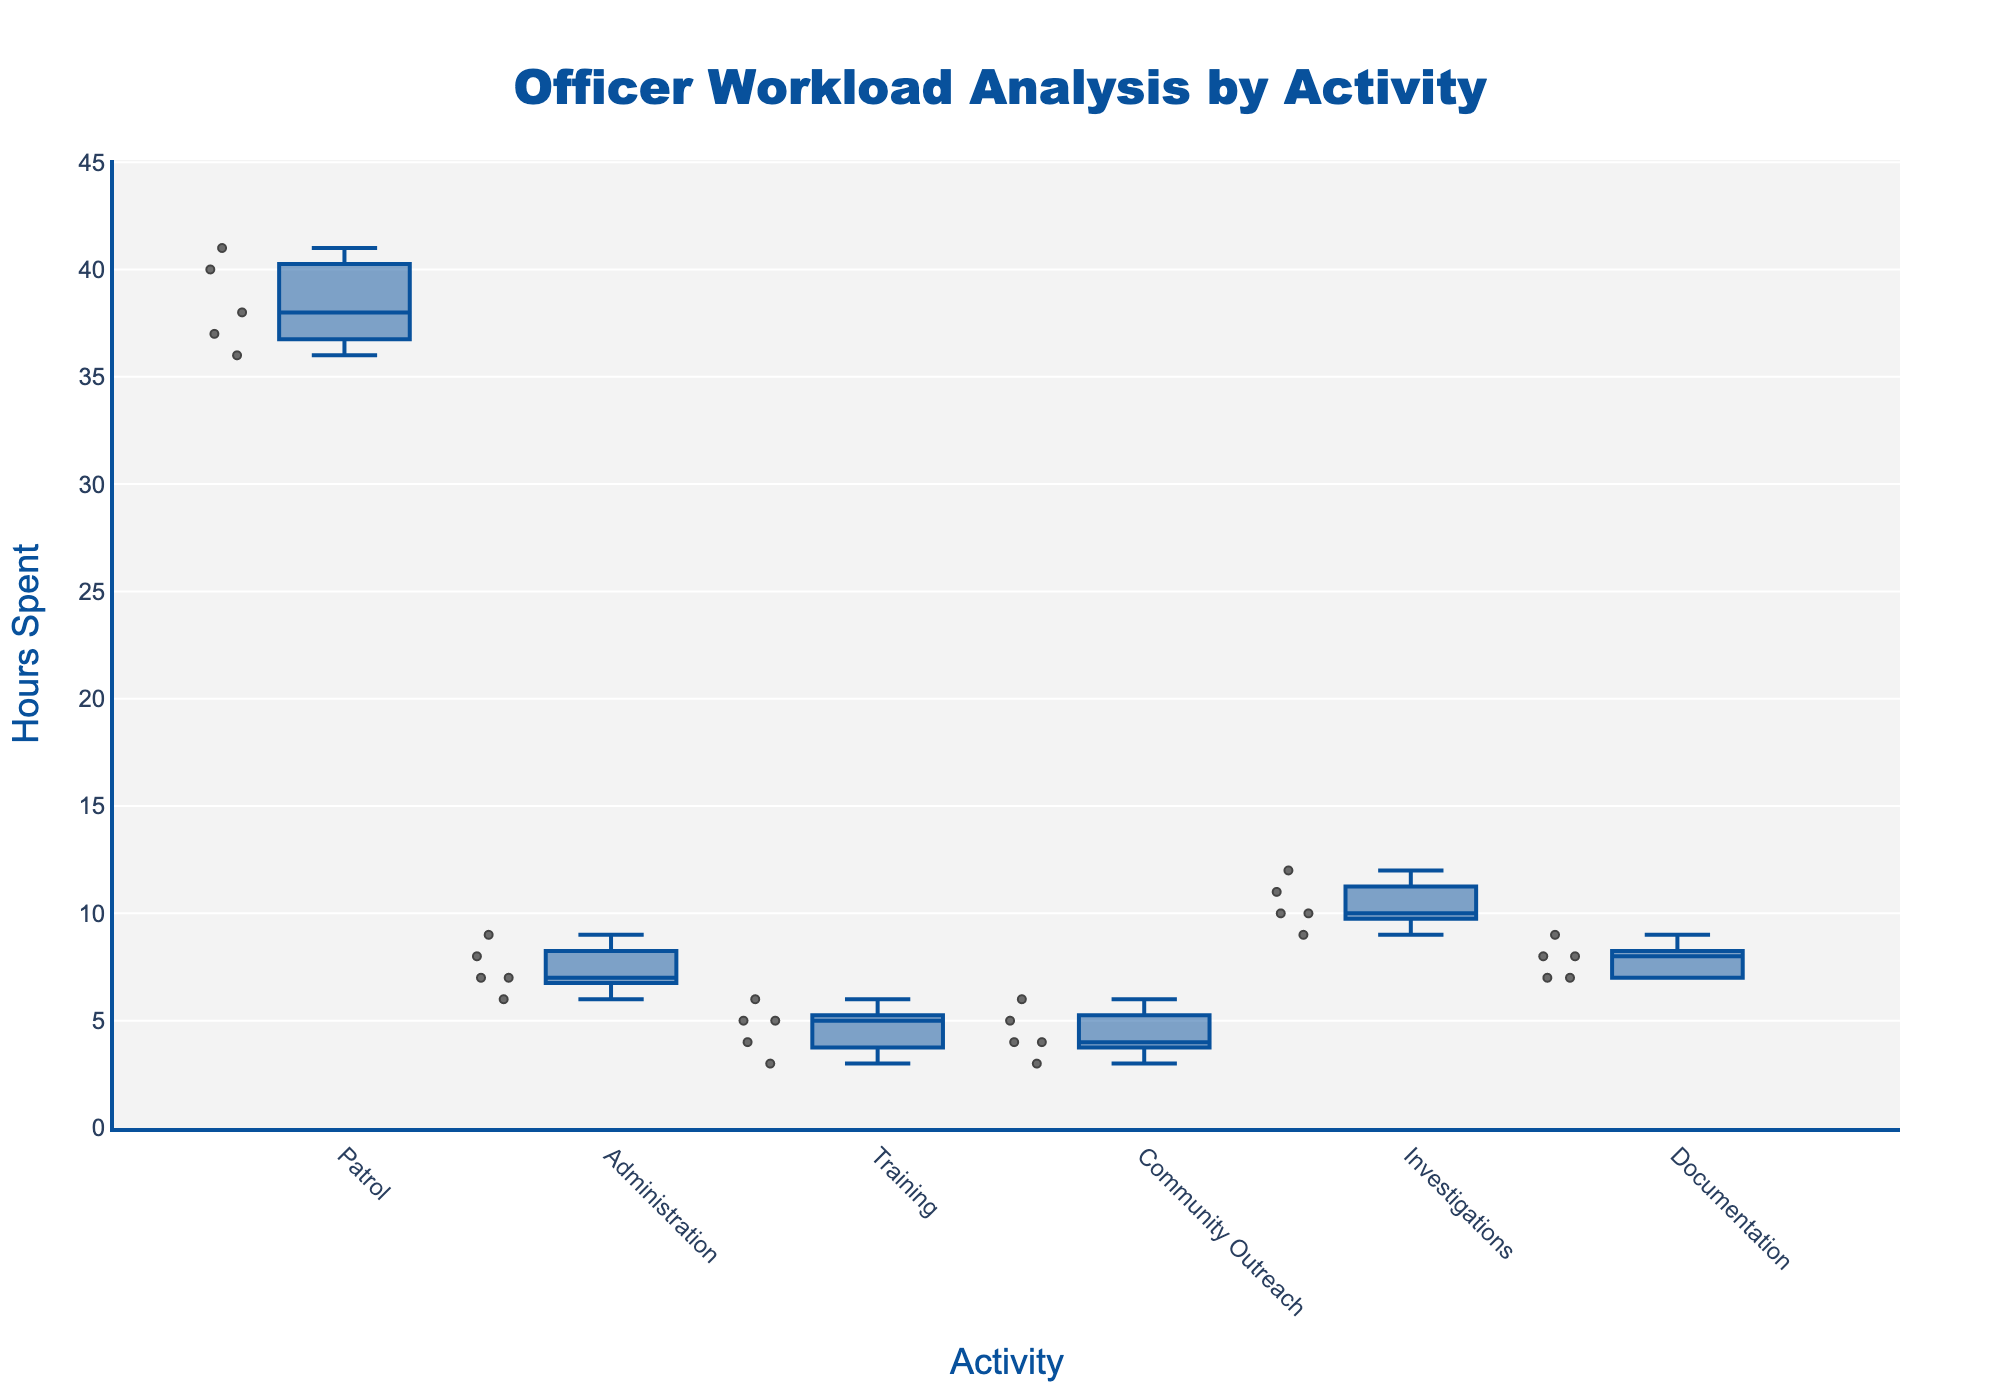What is the title of the figure? The title is located at the top center of the figure and is visually distinct due to its larger font size and color.
Answer: Officer Workload Analysis by Activity Which activity has the highest median number of hours? To determine the median, look at the middle line inside each box. The box representing 'Patrol' has the highest median value.
Answer: Patrol How many activities have median hours between 5 and 10? Count the number of boxes whose middle lines fall between 5 and 10 on the y-axis. Four activities have their medians in this range: Administration, Training, Community Outreach, and Documentation.
Answer: Four Which activity appears to have the most variability in hours? Variability can be assessed by looking at the length of the whiskers (the lines extending from the boxes) and the spread of the points. 'Investigations' shows the largest spread.
Answer: Investigations What's the difference between the maximum hours spent on 'Patrol' and 'Community Outreach'? Identify the top whisker ends for 'Patrol' and 'Community Outreach'. The maximum for 'Patrol' is around 41, and for 'Community Outreach' it's around 6, resulting in a difference of 35 hours.
Answer: 35 hours Which activity has the least number of outliers? Outliers are indicated by individual points outside the whiskers. 'Training' has the least number of outliers, with nearly none visible beyond the whiskers.
Answer: Training How does 'Administration' compare to 'Investigation' in terms of median hours? Compare the middle lines of the boxes for both activities. 'Investigation' has a higher median than 'Administration'.
Answer: Investigation has a higher median What is the range of hours for 'Documentation'? The range is the difference between the highest and lowest points within the whiskers. For 'Documentation', it spans from about 7 to 9, giving a range of 2 hours.
Answer: 2 hours What's the median value of hours spent on 'Training'? The median is indicated by the middle line inside the 'Training' box. This line is around the 4-hour mark.
Answer: 4 hours 